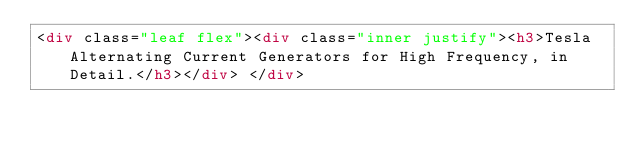<code> <loc_0><loc_0><loc_500><loc_500><_HTML_><div class="leaf flex"><div class="inner justify"><h3>Tesla Alternating Current Generators for High Frequency, in Detail.</h3></div> </div></code> 